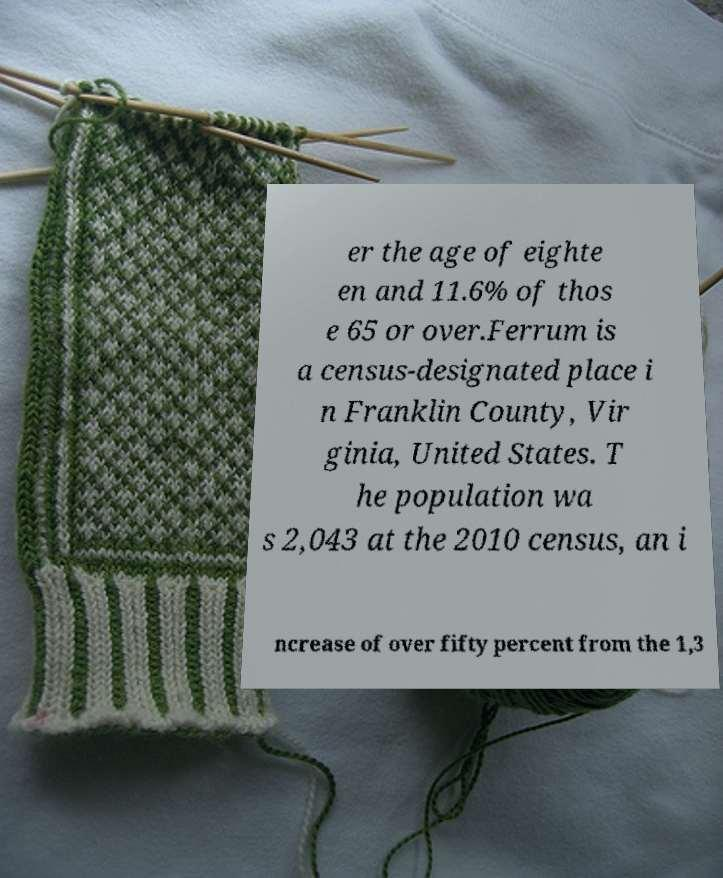What messages or text are displayed in this image? I need them in a readable, typed format. er the age of eighte en and 11.6% of thos e 65 or over.Ferrum is a census-designated place i n Franklin County, Vir ginia, United States. T he population wa s 2,043 at the 2010 census, an i ncrease of over fifty percent from the 1,3 